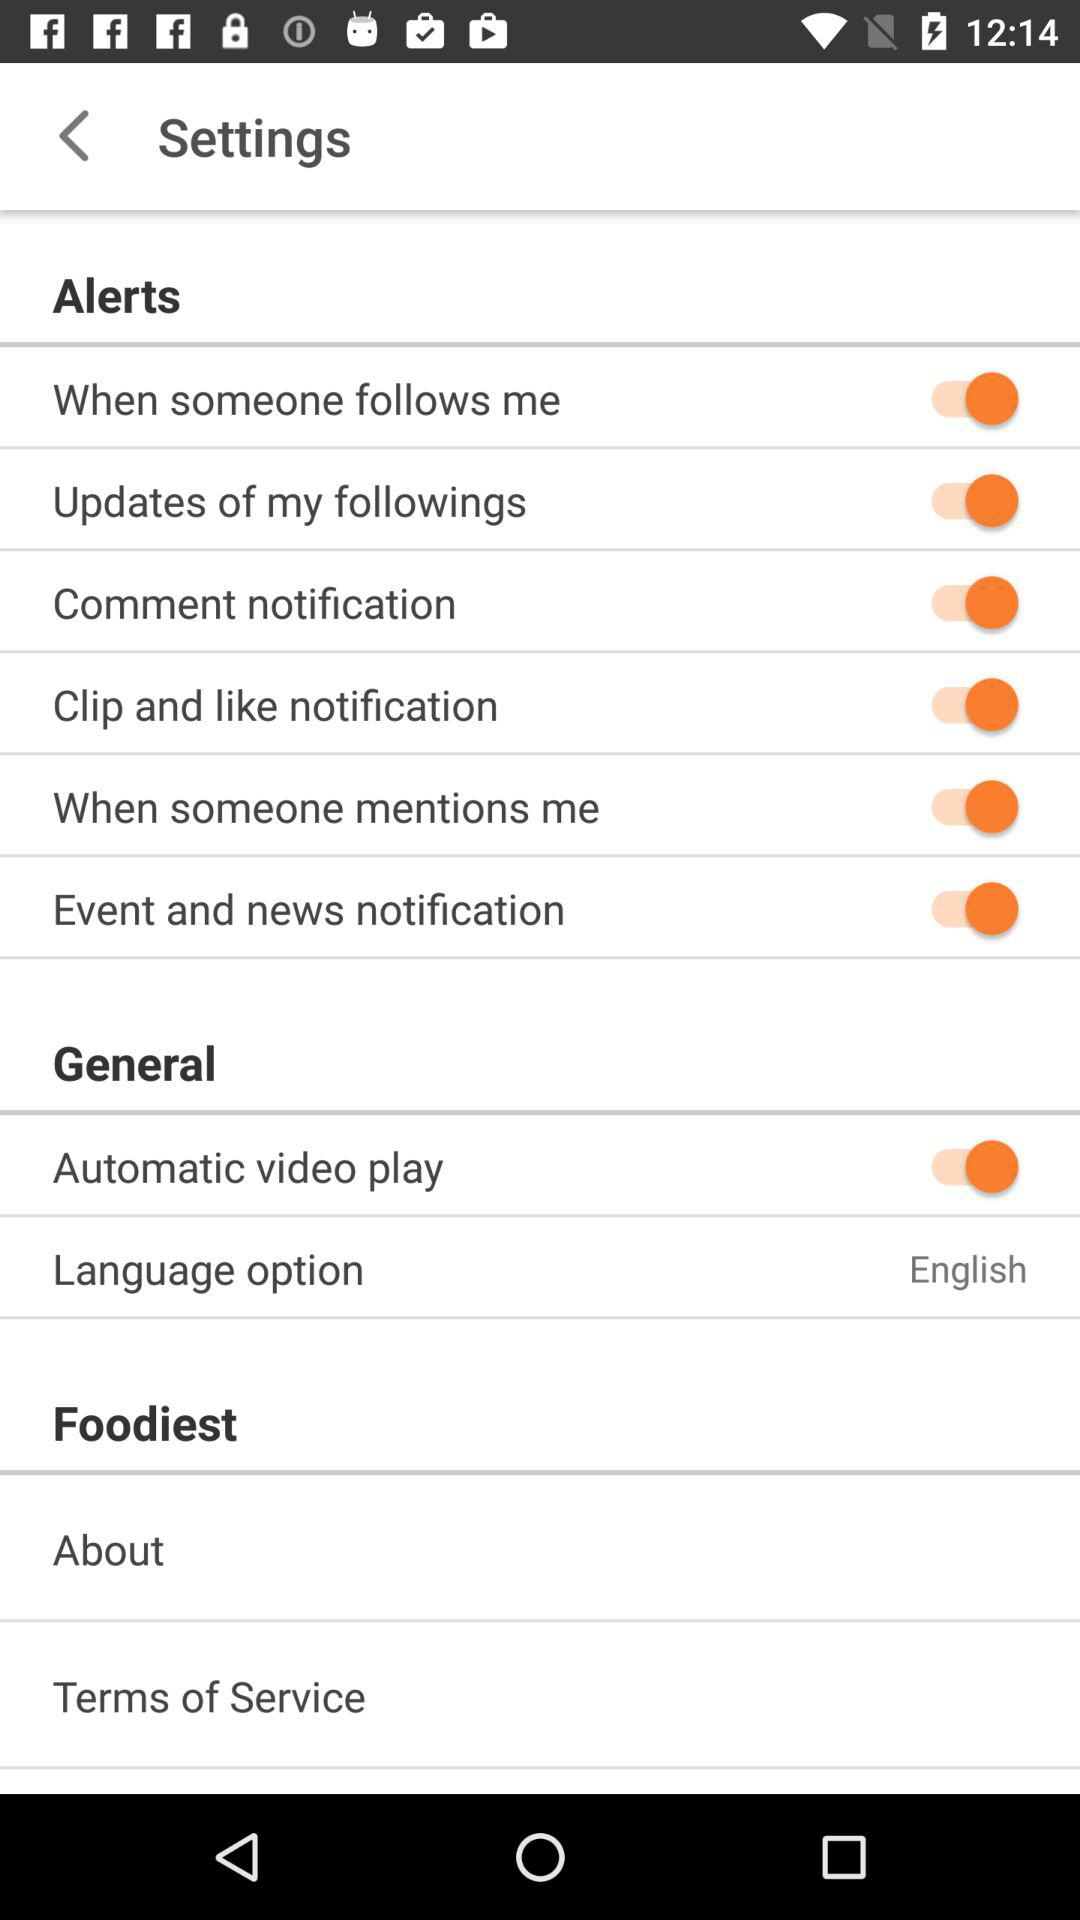What is the status of "Comment notification"? The status is "on". 